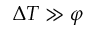<formula> <loc_0><loc_0><loc_500><loc_500>\Delta T \gg \varphi</formula> 